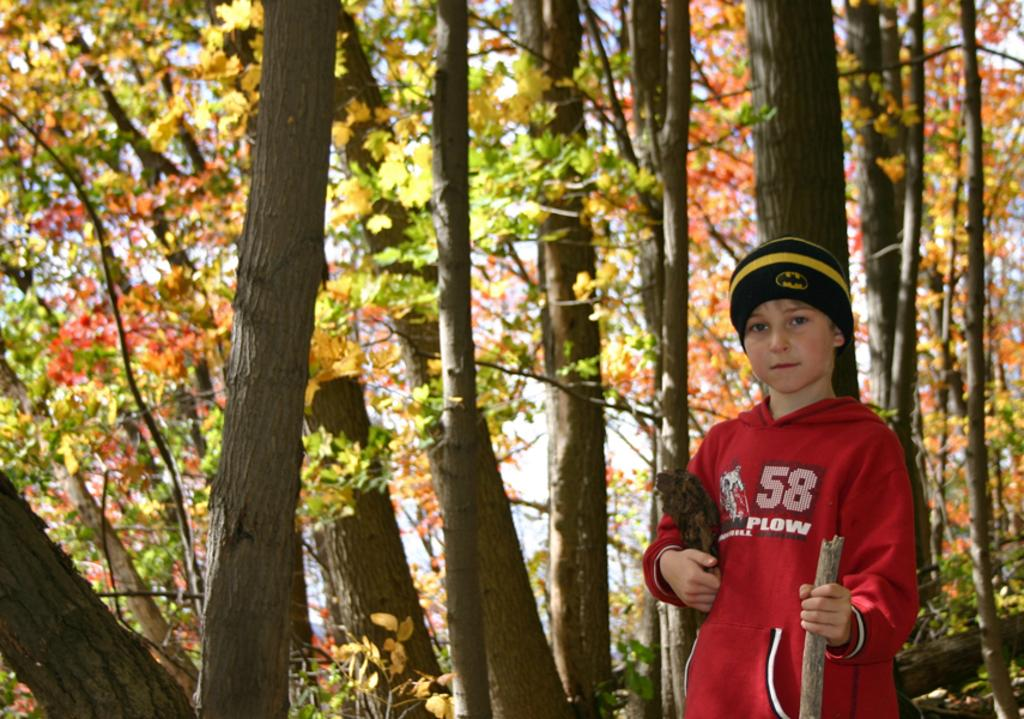<image>
Relay a brief, clear account of the picture shown. A kid wears a red shirt with the number 58 and the word plow on it. 